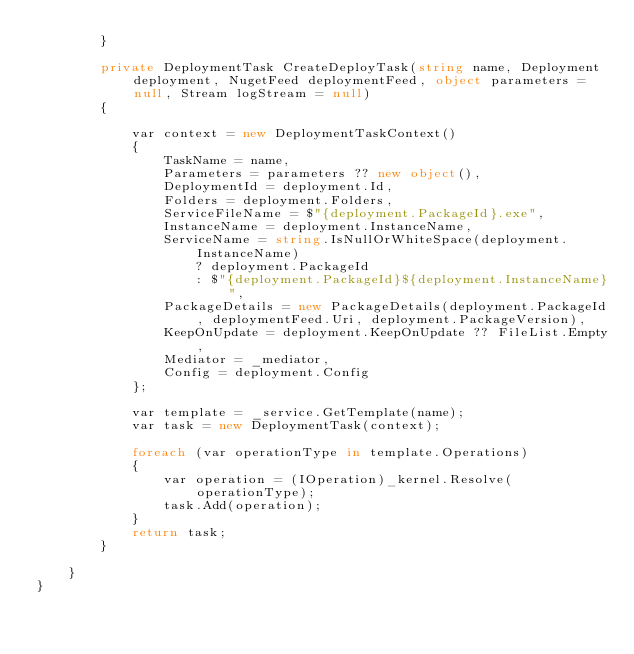<code> <loc_0><loc_0><loc_500><loc_500><_C#_>        }

        private DeploymentTask CreateDeployTask(string name, Deployment deployment, NugetFeed deploymentFeed, object parameters = null, Stream logStream = null)
        {

            var context = new DeploymentTaskContext()
            {
                TaskName = name,
                Parameters = parameters ?? new object(),
                DeploymentId = deployment.Id,
                Folders = deployment.Folders,
                ServiceFileName = $"{deployment.PackageId}.exe",
                InstanceName = deployment.InstanceName,
                ServiceName = string.IsNullOrWhiteSpace(deployment.InstanceName)
                    ? deployment.PackageId
                    : $"{deployment.PackageId}${deployment.InstanceName}",
                PackageDetails = new PackageDetails(deployment.PackageId, deploymentFeed.Uri, deployment.PackageVersion),
                KeepOnUpdate = deployment.KeepOnUpdate ?? FileList.Empty,
                Mediator = _mediator,
                Config = deployment.Config
            };

            var template = _service.GetTemplate(name);
            var task = new DeploymentTask(context);

            foreach (var operationType in template.Operations)
            {
                var operation = (IOperation)_kernel.Resolve(operationType);
                task.Add(operation);
            }
            return task;
        }

    }
}</code> 